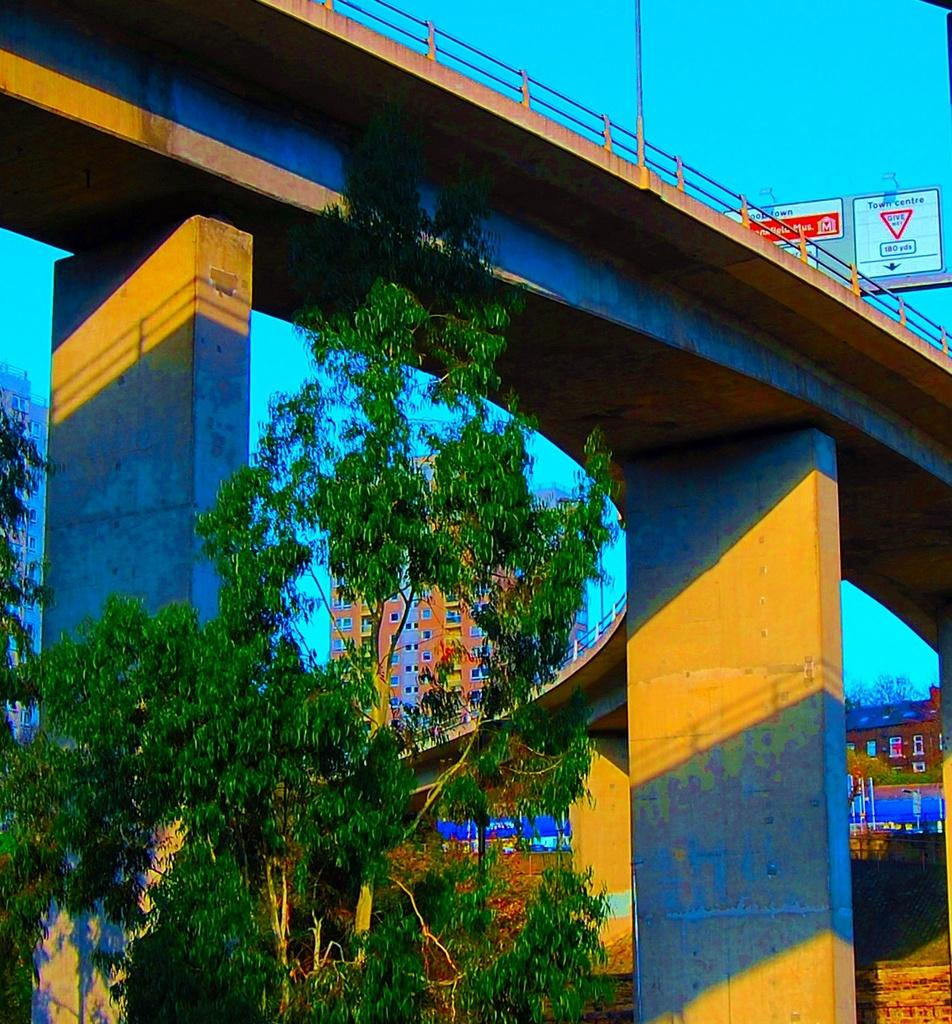What is located at the front of the image? There is a tree in the front of the image. What structure can be seen in the image? There is a bridge in the image. What can be seen in the background of the image? There are buildings in the background of the image. What is written on the boards at the top of the bridge? There are boards with text on the top of the bridge. Can you see a hand holding an orange in the image? There is no hand holding an orange in the image. What type of teaching is happening on the bridge in the image? There is no teaching happening in the image; it only shows a bridge with boards containing text. 